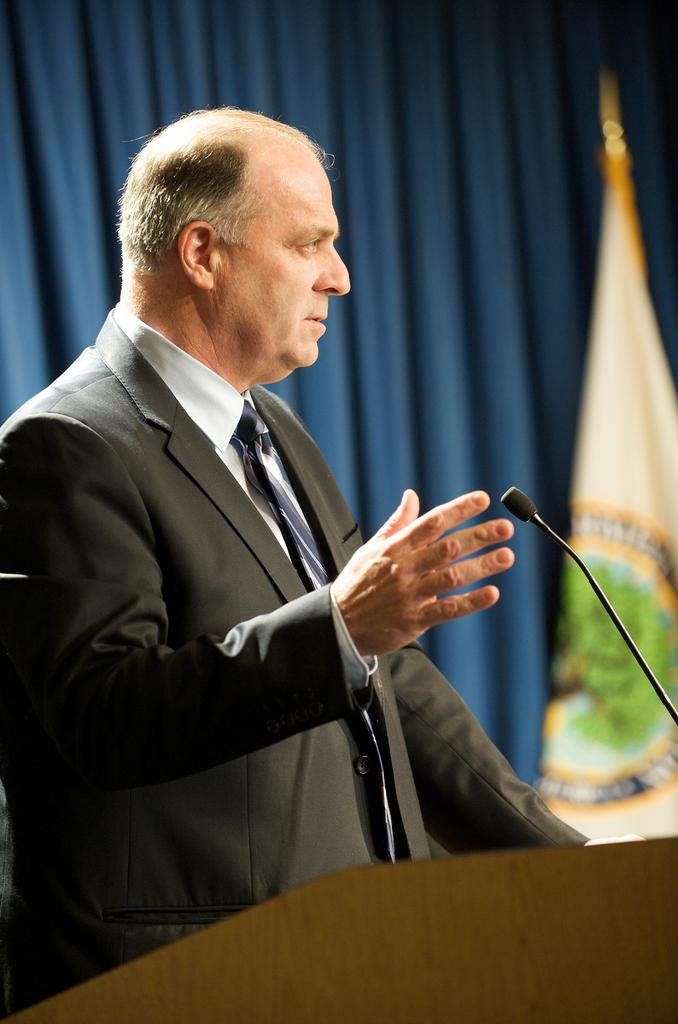Who is present in the image? There is a man in the image. What is the man wearing? The man is wearing a suit. Where is the man standing in relation to another object? The man is standing near a podium. What can be seen in the background of the image? There is a curtain and a flag in the background of the image. What type of fowl can be seen flying in the image? There is no fowl present in the image; it features a man standing near a podium with a curtain and a flag in the background. 